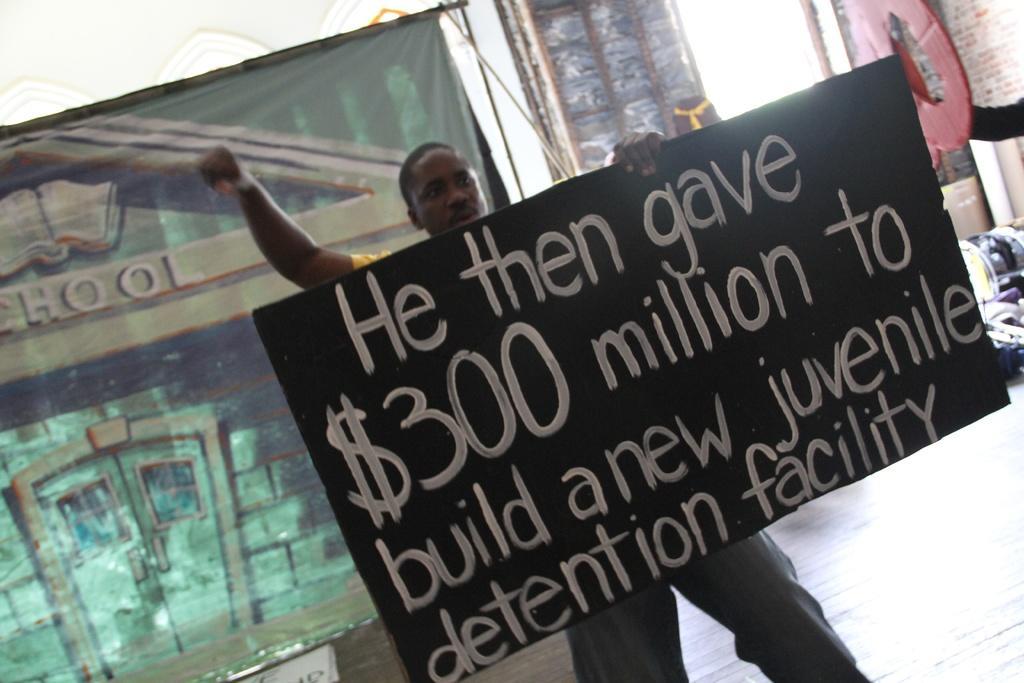In one or two sentences, can you explain what this image depicts? In this picture we can see a person holding a board, on this board we can see some text on it and in the background we can see a banner, floor, wall and some objects. 